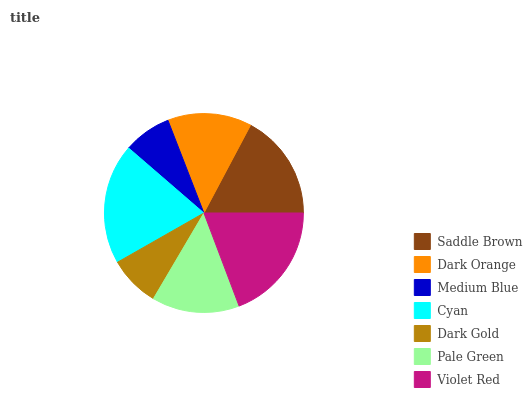Is Medium Blue the minimum?
Answer yes or no. Yes. Is Cyan the maximum?
Answer yes or no. Yes. Is Dark Orange the minimum?
Answer yes or no. No. Is Dark Orange the maximum?
Answer yes or no. No. Is Saddle Brown greater than Dark Orange?
Answer yes or no. Yes. Is Dark Orange less than Saddle Brown?
Answer yes or no. Yes. Is Dark Orange greater than Saddle Brown?
Answer yes or no. No. Is Saddle Brown less than Dark Orange?
Answer yes or no. No. Is Pale Green the high median?
Answer yes or no. Yes. Is Pale Green the low median?
Answer yes or no. Yes. Is Dark Orange the high median?
Answer yes or no. No. Is Violet Red the low median?
Answer yes or no. No. 